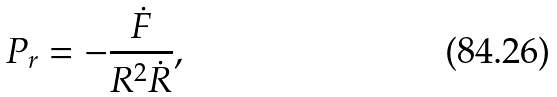<formula> <loc_0><loc_0><loc_500><loc_500>P _ { r } = - \frac { \dot { F } } { R ^ { 2 } \dot { R } } ,</formula> 